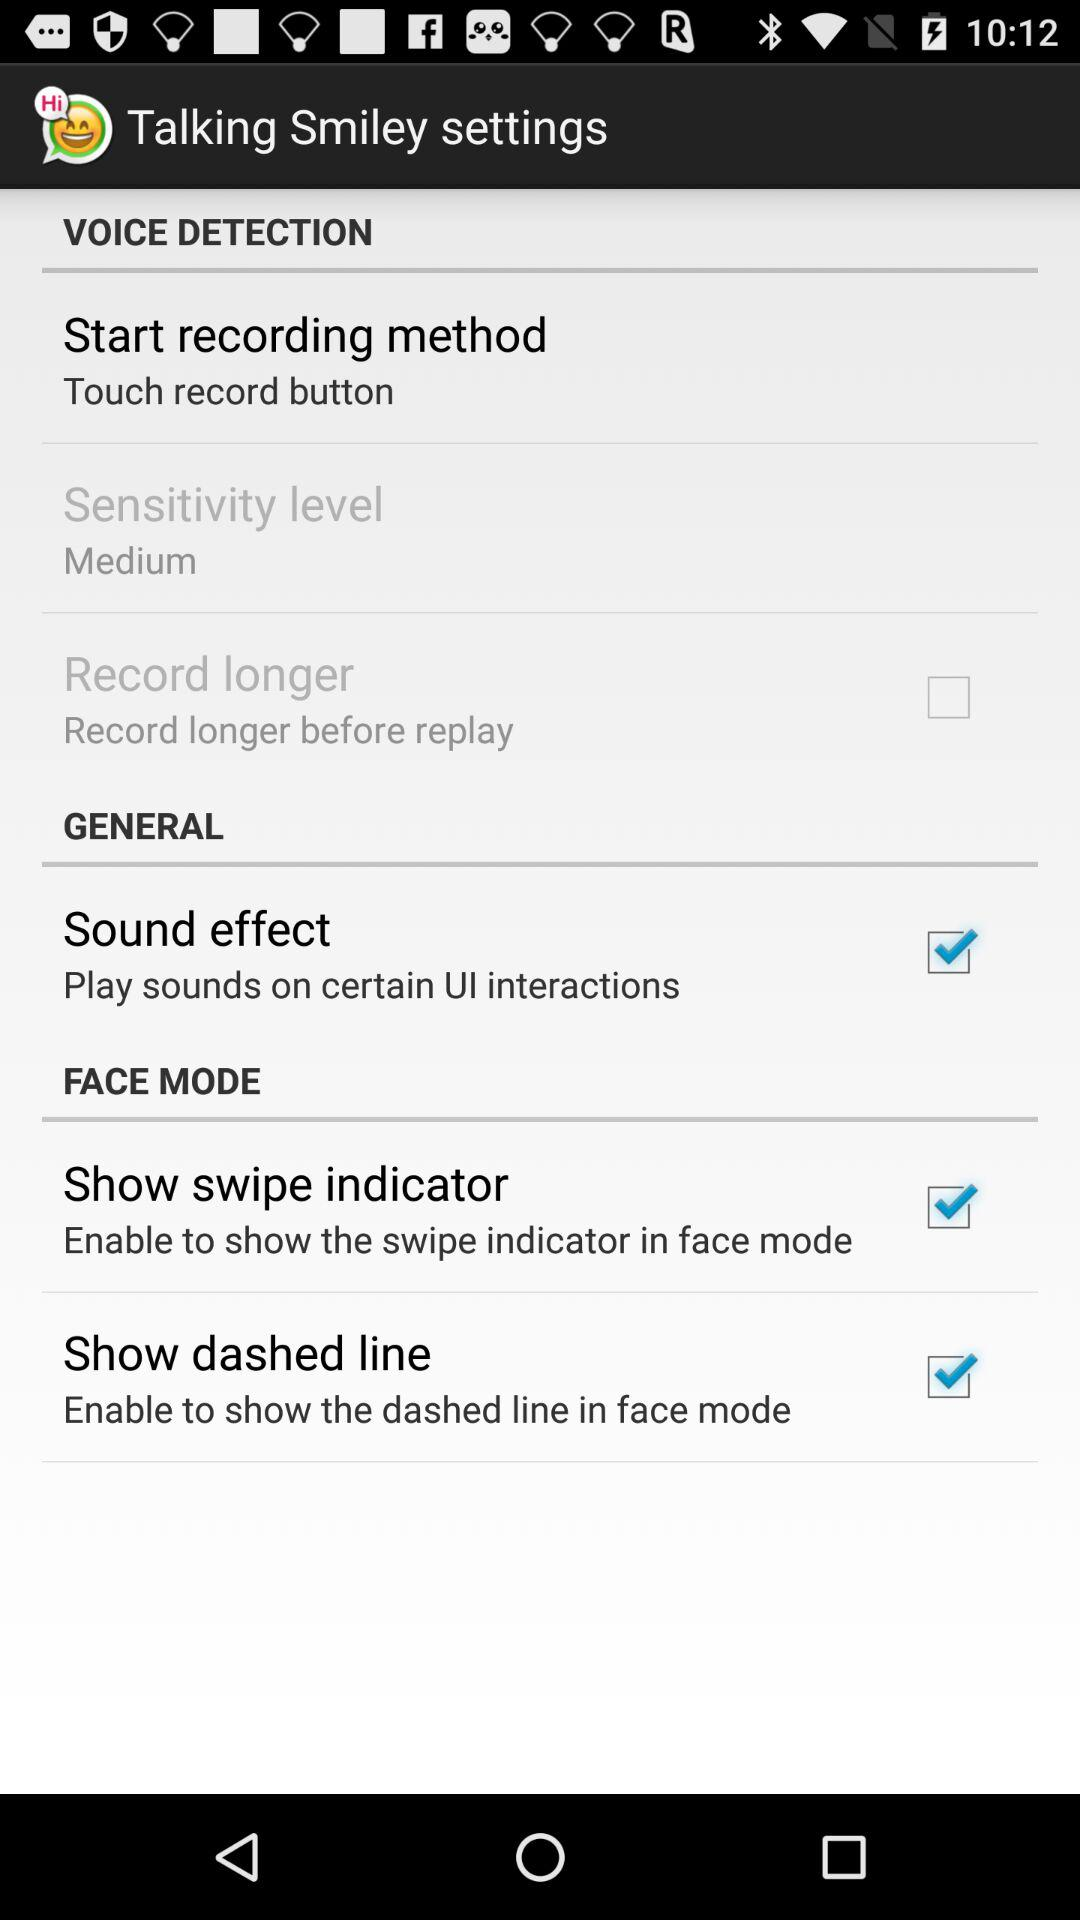What's the setting for the "Start recording method"? The setting for the "Start recording method" is "Touch record button". 